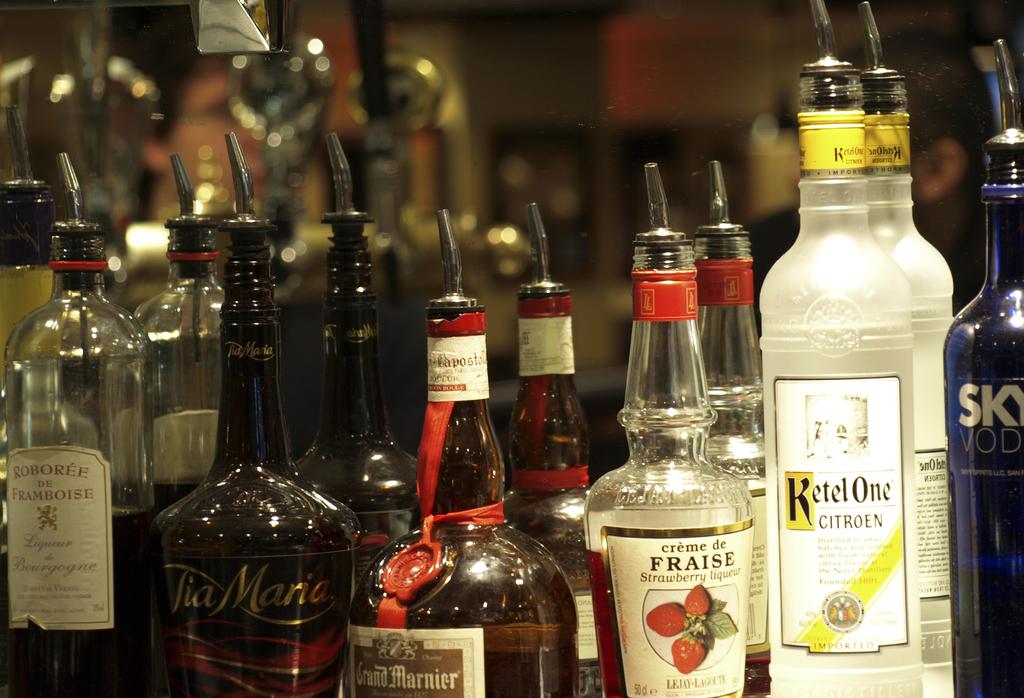What is the yellow bottle called?
Your answer should be compact. Ketel one. 